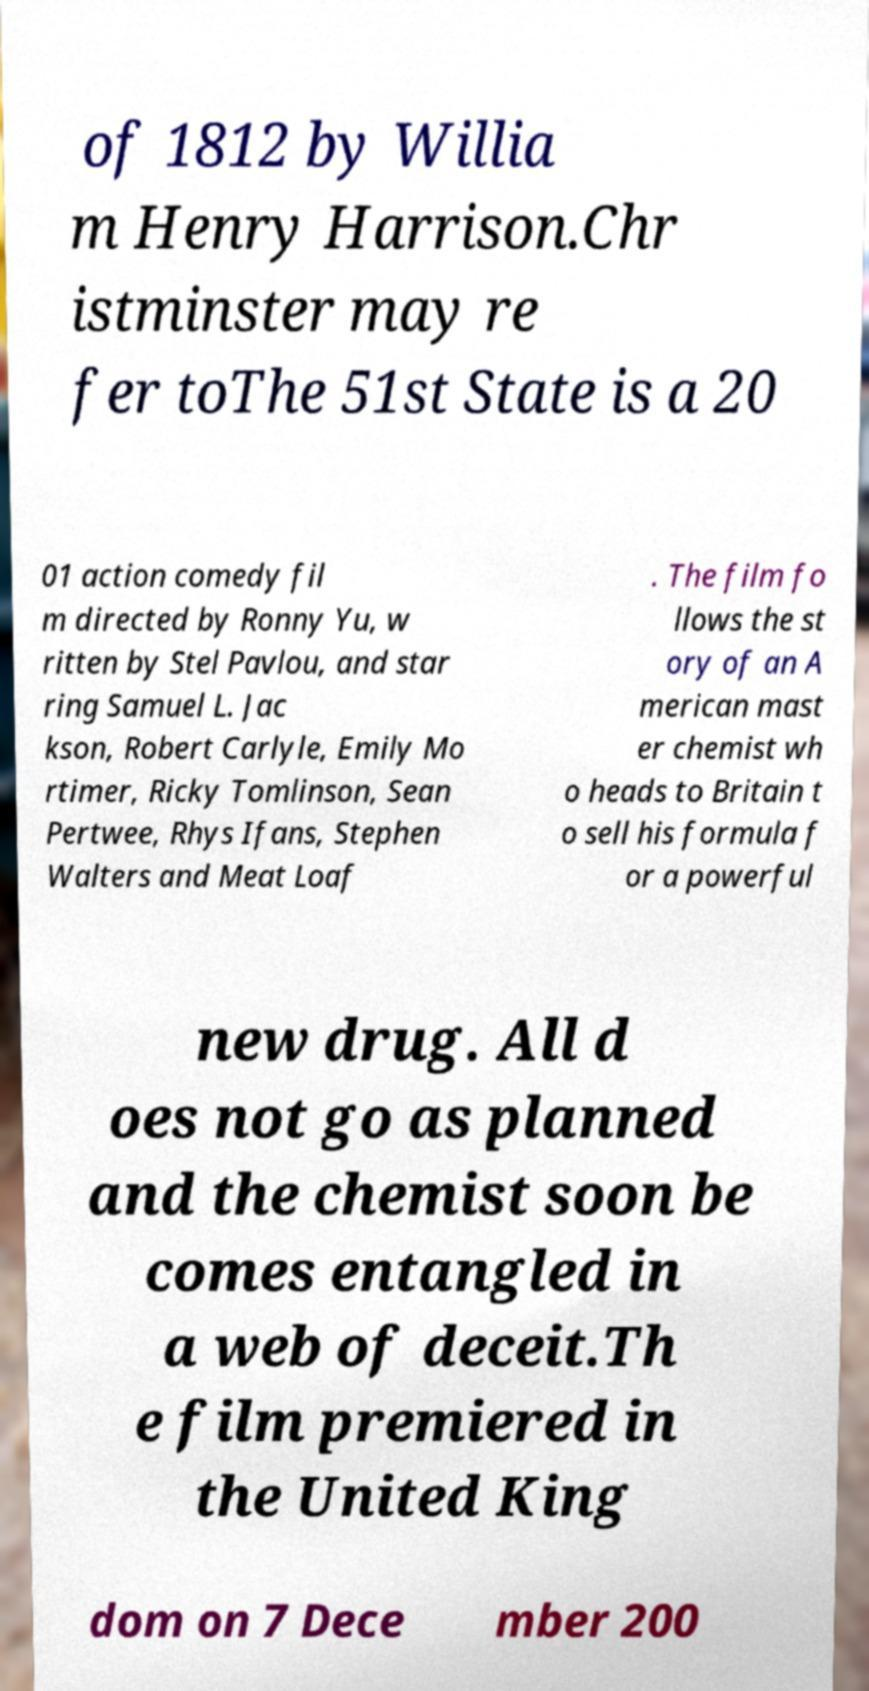I need the written content from this picture converted into text. Can you do that? of 1812 by Willia m Henry Harrison.Chr istminster may re fer toThe 51st State is a 20 01 action comedy fil m directed by Ronny Yu, w ritten by Stel Pavlou, and star ring Samuel L. Jac kson, Robert Carlyle, Emily Mo rtimer, Ricky Tomlinson, Sean Pertwee, Rhys Ifans, Stephen Walters and Meat Loaf . The film fo llows the st ory of an A merican mast er chemist wh o heads to Britain t o sell his formula f or a powerful new drug. All d oes not go as planned and the chemist soon be comes entangled in a web of deceit.Th e film premiered in the United King dom on 7 Dece mber 200 